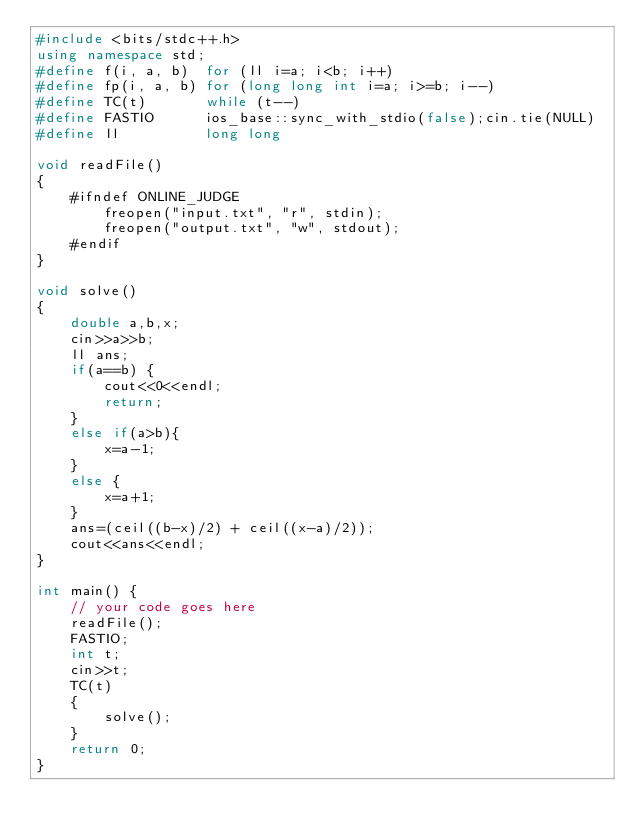Convert code to text. <code><loc_0><loc_0><loc_500><loc_500><_C++_>#include <bits/stdc++.h>
using namespace std;
#define f(i, a, b)  for (ll i=a; i<b; i++)
#define fp(i, a, b) for (long long int i=a; i>=b; i--)
#define TC(t)       while (t--)
#define FASTIO      ios_base::sync_with_stdio(false);cin.tie(NULL)
#define ll          long long

void readFile() 
{
    #ifndef ONLINE_JUDGE
	    freopen("input.txt", "r", stdin);
	    freopen("output.txt", "w", stdout);
    #endif
}

void solve()
{
    double a,b,x;
    cin>>a>>b;
    ll ans;
    if(a==b) {
        cout<<0<<endl;
        return;
    }
    else if(a>b){
        x=a-1;
    }
    else {
        x=a+1;
    }
    ans=(ceil((b-x)/2) + ceil((x-a)/2));
    cout<<ans<<endl;
}

int main() {
	// your code goes here
	readFile();
	FASTIO;
    int t;
    cin>>t;
    TC(t)
    {
        solve();
    }
	return 0;
}
</code> 